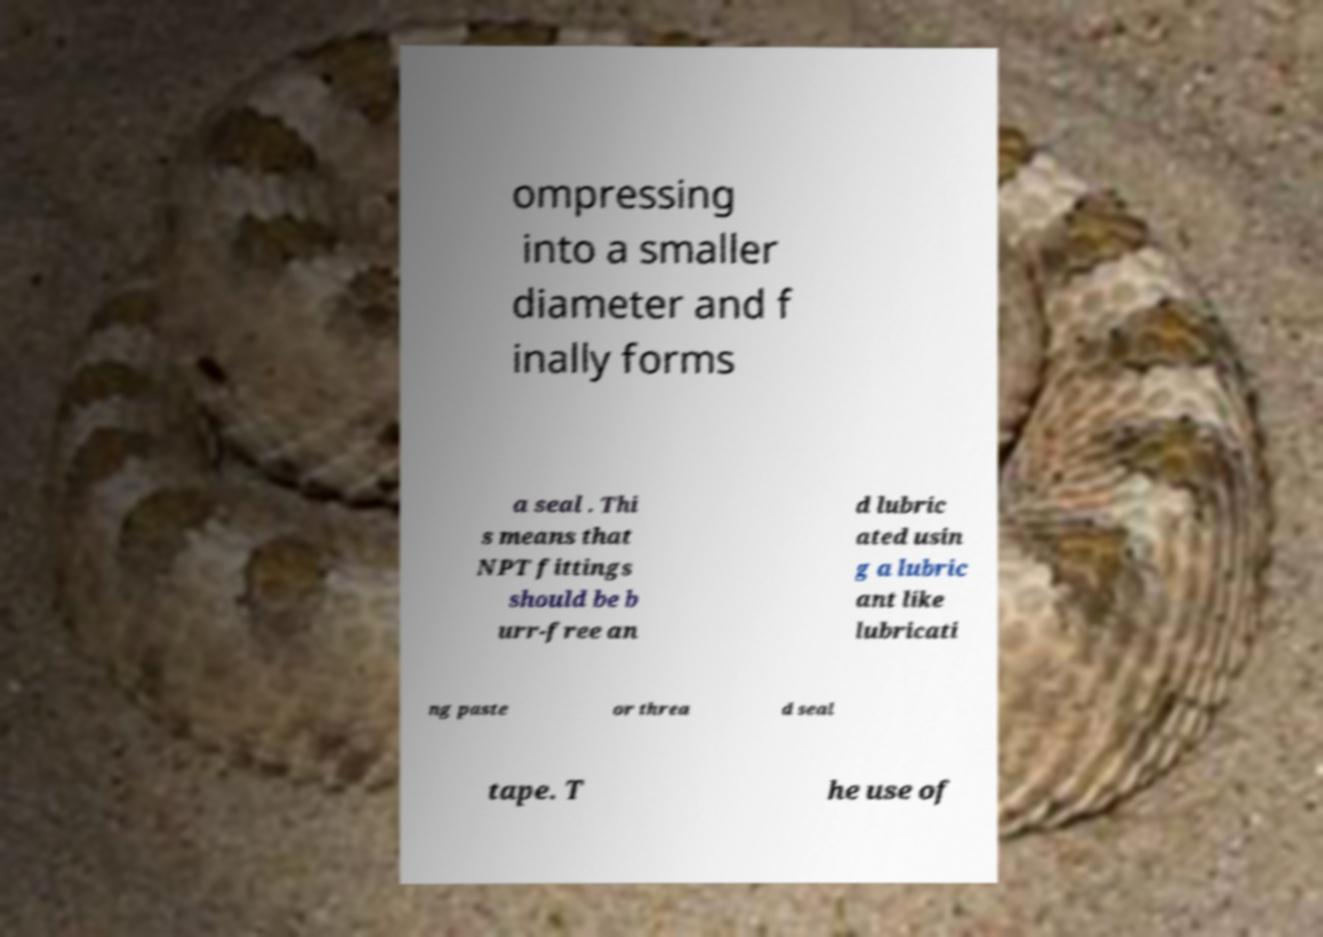For documentation purposes, I need the text within this image transcribed. Could you provide that? ompressing into a smaller diameter and f inally forms a seal . Thi s means that NPT fittings should be b urr-free an d lubric ated usin g a lubric ant like lubricati ng paste or threa d seal tape. T he use of 